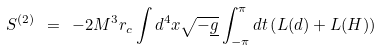<formula> <loc_0><loc_0><loc_500><loc_500>S ^ { ( 2 ) } \ = \ - 2 M ^ { 3 } r _ { c } \int d ^ { 4 } x \sqrt { - \underline { g } } \int _ { - \pi } ^ { \pi } d t \left ( L ( d ) + L ( H ) \right )</formula> 